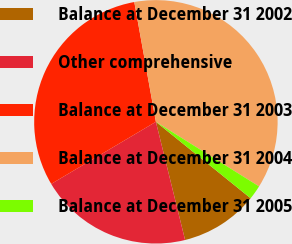Convert chart to OTSL. <chart><loc_0><loc_0><loc_500><loc_500><pie_chart><fcel>Balance at December 31 2002<fcel>Other comprehensive<fcel>Balance at December 31 2003<fcel>Balance at December 31 2004<fcel>Balance at December 31 2005<nl><fcel>10.34%<fcel>20.33%<fcel>30.68%<fcel>36.74%<fcel>1.9%<nl></chart> 